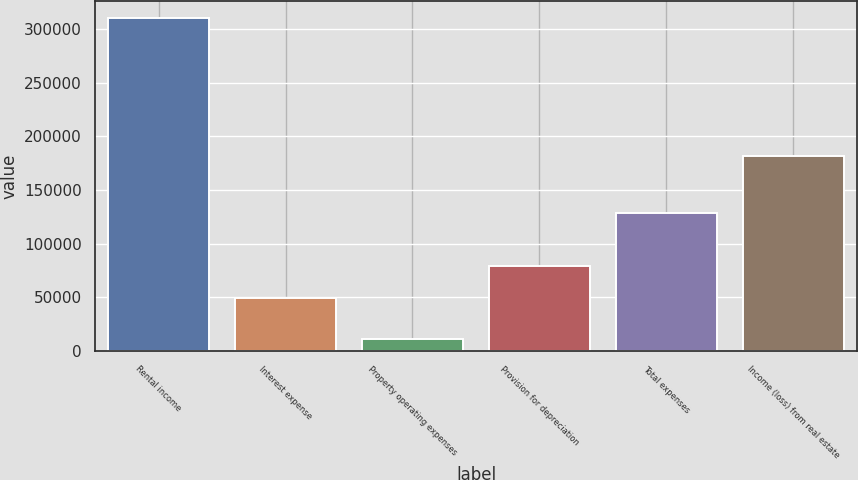Convert chart to OTSL. <chart><loc_0><loc_0><loc_500><loc_500><bar_chart><fcel>Rental income<fcel>Interest expense<fcel>Property operating expenses<fcel>Provision for depreciation<fcel>Total expenses<fcel>Income (loss) from real estate<nl><fcel>310390<fcel>49599<fcel>10846<fcel>79553.4<fcel>128725<fcel>181665<nl></chart> 